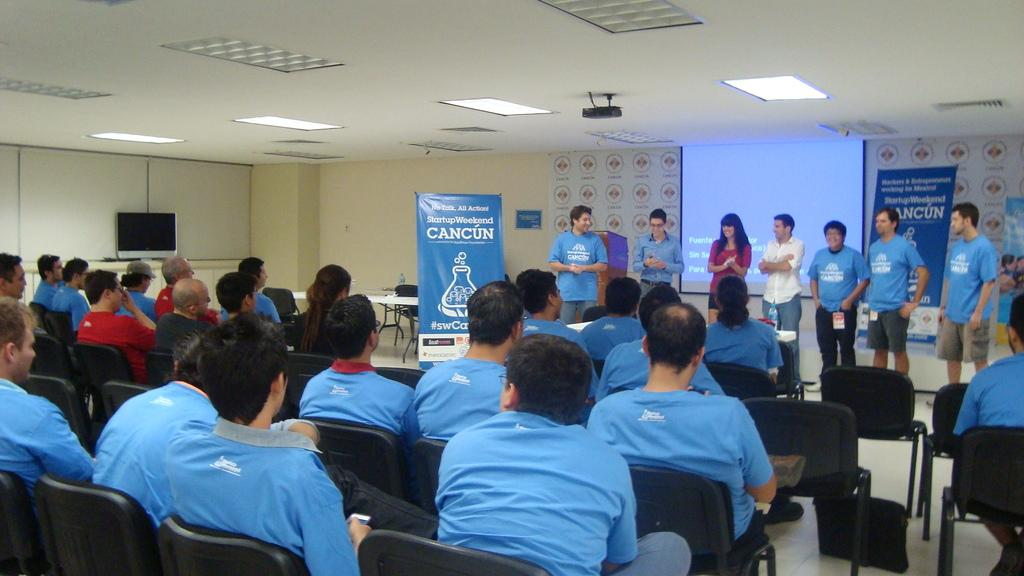How many people are in the image? There is a group of people in the image, but the exact number is not specified. What are the people in the image doing? Some people are sitting, while others are standing. What can be seen hanging or displayed in the image? There is a banner in the image. What is visible in the background of the image? There is a screen in the background of the image. Can you see any hills in the image? There is no mention of hills in the image, so we cannot confirm their presence. Is there any indication of a birth taking place in the image? There is no information about a birth or any related activities in the image. 